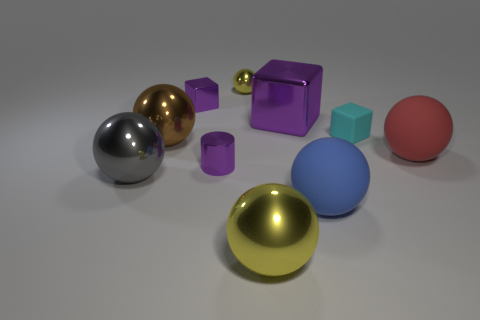Subtract 1 balls. How many balls are left? 5 Subtract all yellow balls. How many balls are left? 4 Subtract all tiny yellow spheres. How many spheres are left? 5 Subtract all brown spheres. Subtract all purple cylinders. How many spheres are left? 5 Subtract all blocks. How many objects are left? 7 Subtract all cyan cubes. Subtract all large balls. How many objects are left? 4 Add 3 yellow metal things. How many yellow metal things are left? 5 Add 4 tiny cyan cubes. How many tiny cyan cubes exist? 5 Subtract 2 purple cubes. How many objects are left? 8 